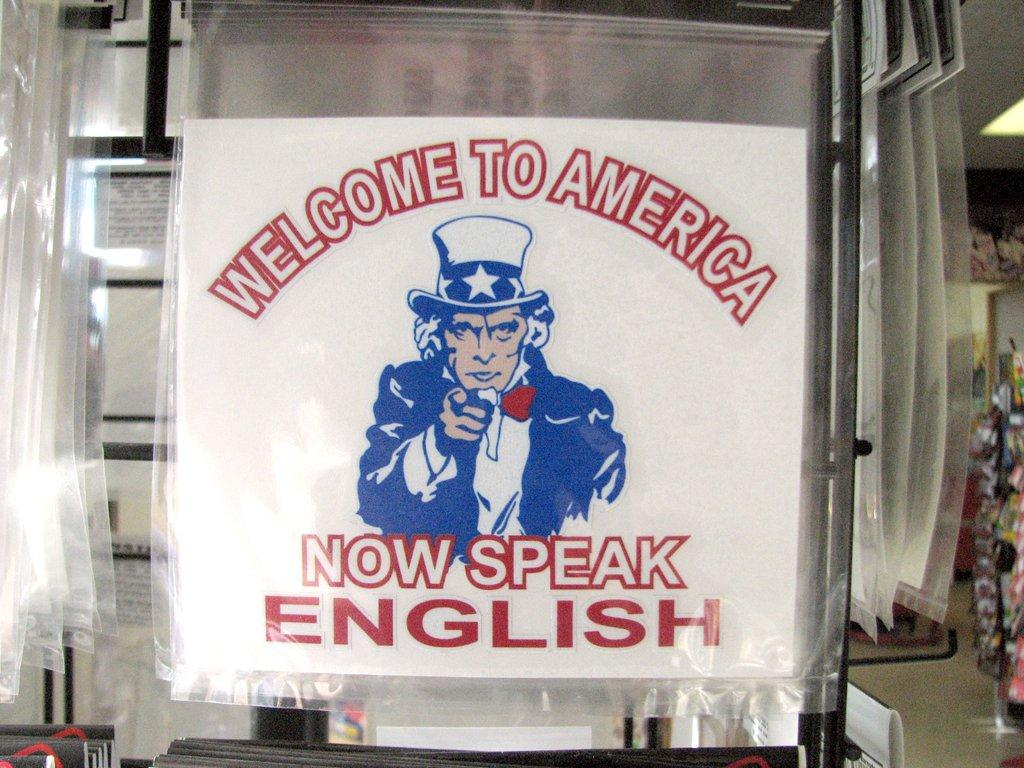<image>
Write a terse but informative summary of the picture. A sign hanging on a display that says "Welcome To America Now Speak English" 